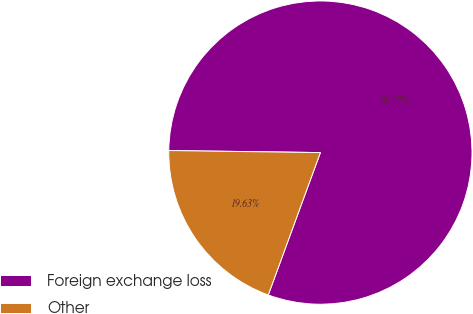Convert chart to OTSL. <chart><loc_0><loc_0><loc_500><loc_500><pie_chart><fcel>Foreign exchange loss<fcel>Other<nl><fcel>80.37%<fcel>19.63%<nl></chart> 